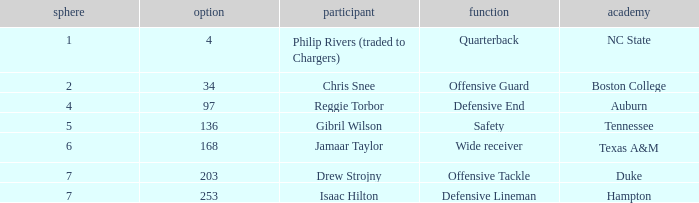Which Selection has a College of texas a&m? 168.0. 